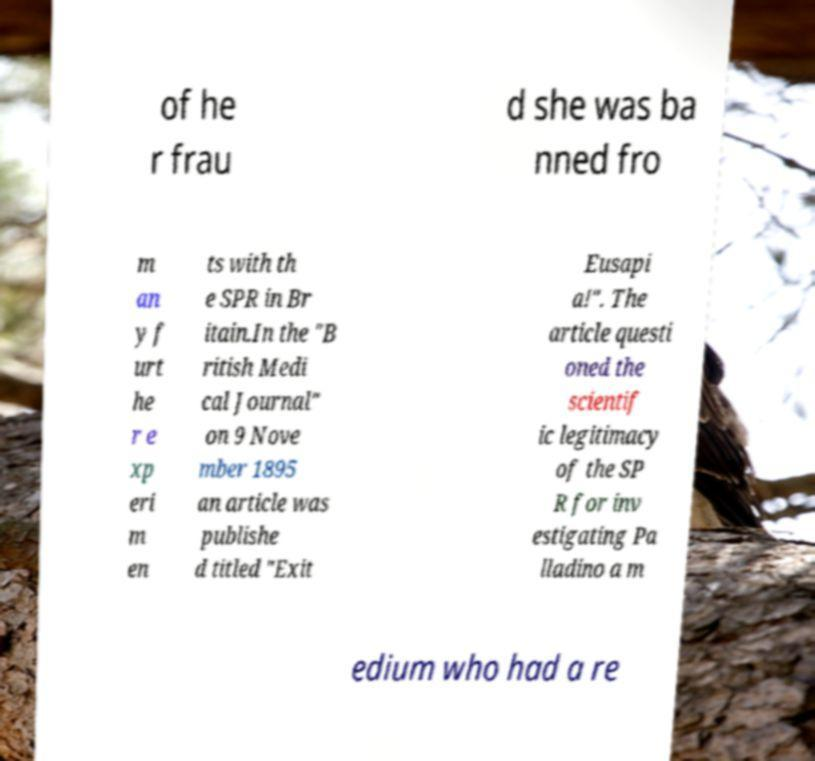Please read and relay the text visible in this image. What does it say? of he r frau d she was ba nned fro m an y f urt he r e xp eri m en ts with th e SPR in Br itain.In the "B ritish Medi cal Journal" on 9 Nove mber 1895 an article was publishe d titled "Exit Eusapi a!". The article questi oned the scientif ic legitimacy of the SP R for inv estigating Pa lladino a m edium who had a re 